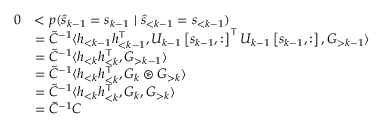<formula> <loc_0><loc_0><loc_500><loc_500>\begin{array} { r l } { 0 } & { < p ( \hat { s } _ { k - 1 } = s _ { k - 1 } \ | \ \hat { s } _ { < k - 1 } = s _ { < k - 1 } ) } \\ & { = \tilde { C } ^ { - 1 } \langle h _ { < k - 1 } h _ { < k - 1 } ^ { \top } , U _ { k - 1 } \left [ s _ { k - 1 } , \colon \right ] ^ { \top } U _ { k - 1 } \left [ s _ { k - 1 } , \colon \right ] , G _ { > k - 1 } \rangle } \\ & { = \tilde { C } ^ { - 1 } \langle h _ { < k } h _ { < k } ^ { \top } , G _ { > k - 1 } \rangle } \\ & { = \tilde { C } ^ { - 1 } \langle h _ { < k } h _ { < k } ^ { \top } , G _ { k } \circledast G _ { > k } \rangle } \\ & { = \tilde { C } ^ { - 1 } \langle h _ { < k } h _ { < k } ^ { \top } , G _ { k } , G _ { > k } \rangle } \\ & { = \tilde { C } ^ { - 1 } C } \end{array}</formula> 